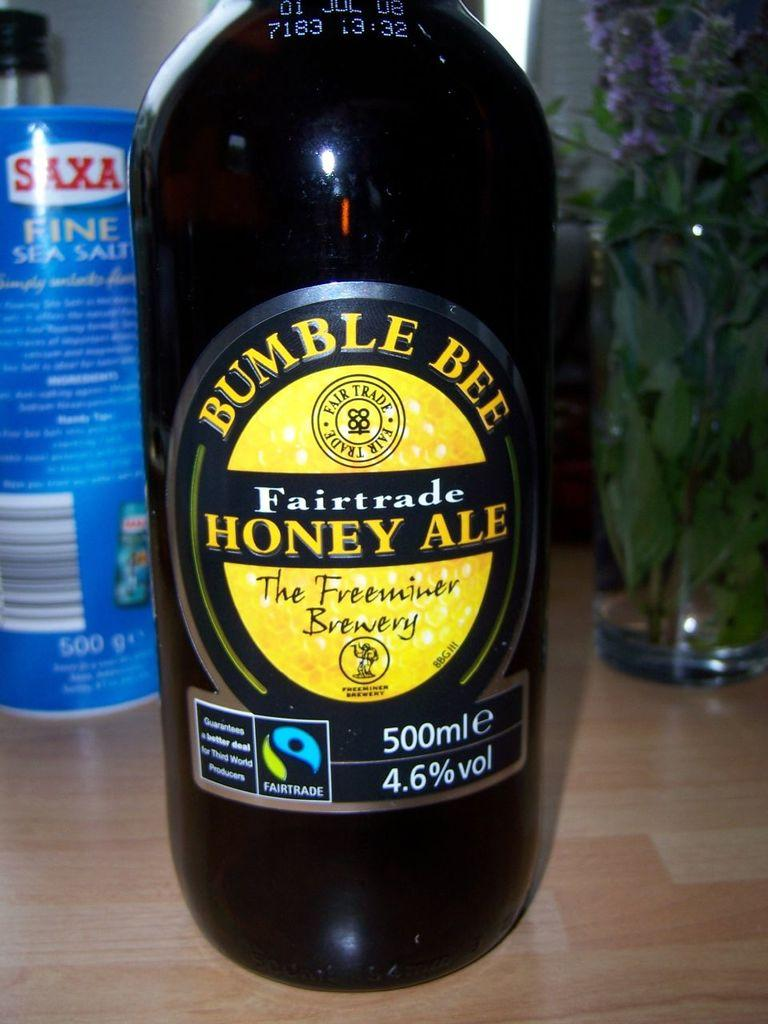Provide a one-sentence caption for the provided image. a 500ml bottle of bumble bee fairtrade honey ale. 